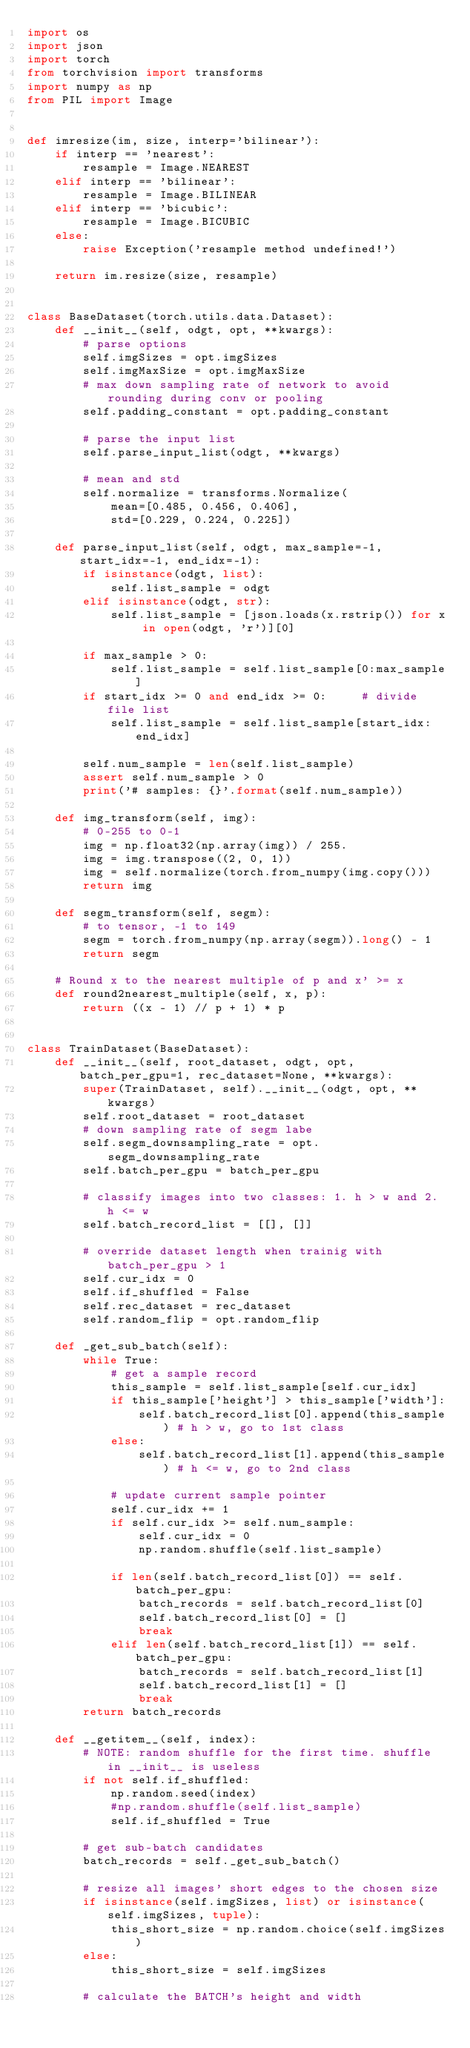<code> <loc_0><loc_0><loc_500><loc_500><_Python_>import os
import json
import torch
from torchvision import transforms
import numpy as np
from PIL import Image


def imresize(im, size, interp='bilinear'):
    if interp == 'nearest':
        resample = Image.NEAREST
    elif interp == 'bilinear':
        resample = Image.BILINEAR
    elif interp == 'bicubic':
        resample = Image.BICUBIC
    else:
        raise Exception('resample method undefined!')

    return im.resize(size, resample)


class BaseDataset(torch.utils.data.Dataset):
    def __init__(self, odgt, opt, **kwargs):
        # parse options
        self.imgSizes = opt.imgSizes
        self.imgMaxSize = opt.imgMaxSize
        # max down sampling rate of network to avoid rounding during conv or pooling
        self.padding_constant = opt.padding_constant

        # parse the input list
        self.parse_input_list(odgt, **kwargs)

        # mean and std
        self.normalize = transforms.Normalize(
            mean=[0.485, 0.456, 0.406],
            std=[0.229, 0.224, 0.225])

    def parse_input_list(self, odgt, max_sample=-1, start_idx=-1, end_idx=-1):
        if isinstance(odgt, list):
            self.list_sample = odgt
        elif isinstance(odgt, str):
            self.list_sample = [json.loads(x.rstrip()) for x in open(odgt, 'r')][0]

        if max_sample > 0:
            self.list_sample = self.list_sample[0:max_sample]
        if start_idx >= 0 and end_idx >= 0:     # divide file list
            self.list_sample = self.list_sample[start_idx:end_idx]

        self.num_sample = len(self.list_sample)
        assert self.num_sample > 0
        print('# samples: {}'.format(self.num_sample))

    def img_transform(self, img):
        # 0-255 to 0-1
        img = np.float32(np.array(img)) / 255.
        img = img.transpose((2, 0, 1))
        img = self.normalize(torch.from_numpy(img.copy()))
        return img

    def segm_transform(self, segm):
        # to tensor, -1 to 149
        segm = torch.from_numpy(np.array(segm)).long() - 1
        return segm

    # Round x to the nearest multiple of p and x' >= x
    def round2nearest_multiple(self, x, p):
        return ((x - 1) // p + 1) * p


class TrainDataset(BaseDataset):
    def __init__(self, root_dataset, odgt, opt, batch_per_gpu=1, rec_dataset=None, **kwargs):
        super(TrainDataset, self).__init__(odgt, opt, **kwargs)
        self.root_dataset = root_dataset
        # down sampling rate of segm labe
        self.segm_downsampling_rate = opt.segm_downsampling_rate
        self.batch_per_gpu = batch_per_gpu

        # classify images into two classes: 1. h > w and 2. h <= w
        self.batch_record_list = [[], []]

        # override dataset length when trainig with batch_per_gpu > 1
        self.cur_idx = 0
        self.if_shuffled = False
        self.rec_dataset = rec_dataset
        self.random_flip = opt.random_flip

    def _get_sub_batch(self):
        while True:
            # get a sample record
            this_sample = self.list_sample[self.cur_idx]
            if this_sample['height'] > this_sample['width']:
                self.batch_record_list[0].append(this_sample) # h > w, go to 1st class
            else:
                self.batch_record_list[1].append(this_sample) # h <= w, go to 2nd class

            # update current sample pointer
            self.cur_idx += 1
            if self.cur_idx >= self.num_sample:
                self.cur_idx = 0
                np.random.shuffle(self.list_sample)

            if len(self.batch_record_list[0]) == self.batch_per_gpu:
                batch_records = self.batch_record_list[0]
                self.batch_record_list[0] = []
                break
            elif len(self.batch_record_list[1]) == self.batch_per_gpu:
                batch_records = self.batch_record_list[1]
                self.batch_record_list[1] = []
                break
        return batch_records

    def __getitem__(self, index):
        # NOTE: random shuffle for the first time. shuffle in __init__ is useless
        if not self.if_shuffled:
            np.random.seed(index)
            #np.random.shuffle(self.list_sample)
            self.if_shuffled = True

        # get sub-batch candidates
        batch_records = self._get_sub_batch()

        # resize all images' short edges to the chosen size
        if isinstance(self.imgSizes, list) or isinstance(self.imgSizes, tuple):
            this_short_size = np.random.choice(self.imgSizes)
        else:
            this_short_size = self.imgSizes

        # calculate the BATCH's height and width</code> 